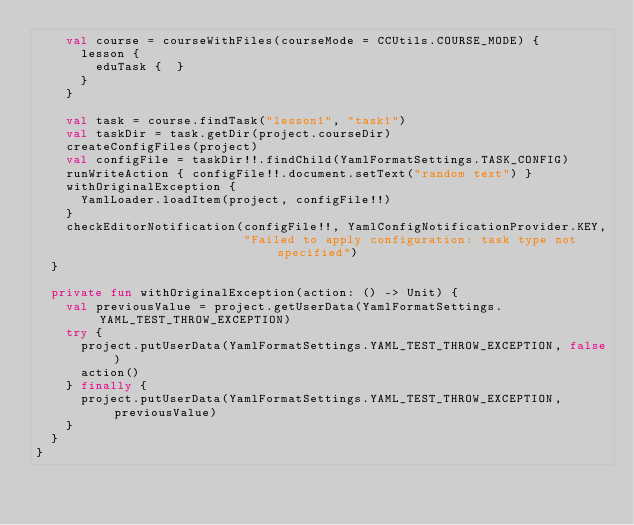Convert code to text. <code><loc_0><loc_0><loc_500><loc_500><_Kotlin_>    val course = courseWithFiles(courseMode = CCUtils.COURSE_MODE) {
      lesson {
        eduTask {  }
      }
    }

    val task = course.findTask("lesson1", "task1")
    val taskDir = task.getDir(project.courseDir)
    createConfigFiles(project)
    val configFile = taskDir!!.findChild(YamlFormatSettings.TASK_CONFIG)
    runWriteAction { configFile!!.document.setText("random text") }
    withOriginalException {
      YamlLoader.loadItem(project, configFile!!)
    }
    checkEditorNotification(configFile!!, YamlConfigNotificationProvider.KEY,
                            "Failed to apply configuration: task type not specified")
  }

  private fun withOriginalException(action: () -> Unit) {
    val previousValue = project.getUserData(YamlFormatSettings.YAML_TEST_THROW_EXCEPTION)
    try {
      project.putUserData(YamlFormatSettings.YAML_TEST_THROW_EXCEPTION, false)
      action()
    } finally {
      project.putUserData(YamlFormatSettings.YAML_TEST_THROW_EXCEPTION, previousValue)
    }
  }
}</code> 